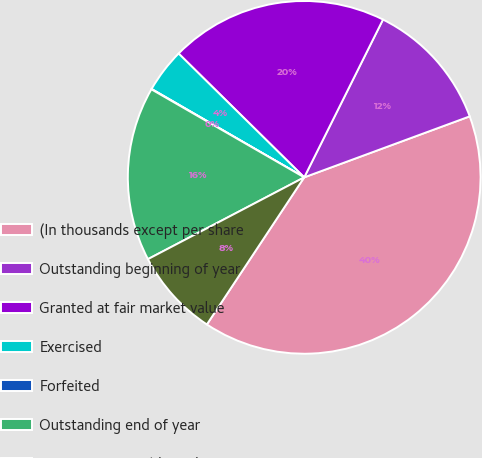Convert chart to OTSL. <chart><loc_0><loc_0><loc_500><loc_500><pie_chart><fcel>(In thousands except per share<fcel>Outstanding beginning of year<fcel>Granted at fair market value<fcel>Exercised<fcel>Forfeited<fcel>Outstanding end of year<fcel>Options exercisable end of<nl><fcel>39.92%<fcel>12.01%<fcel>19.98%<fcel>4.03%<fcel>0.04%<fcel>15.99%<fcel>8.02%<nl></chart> 